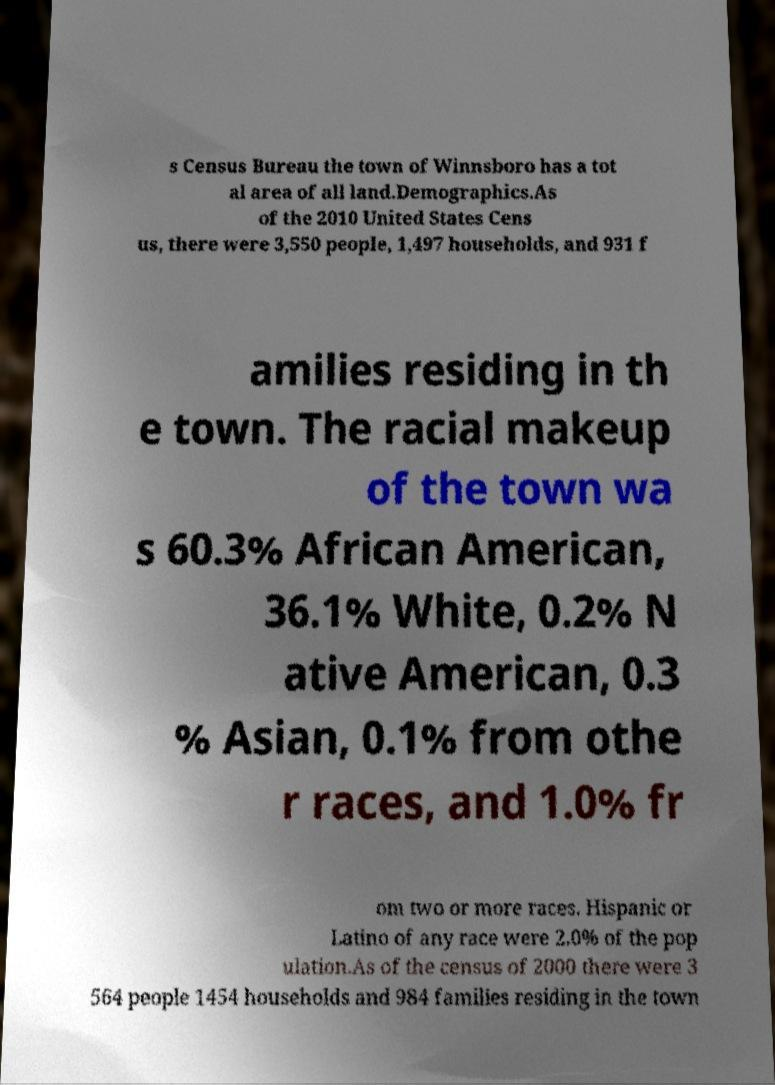Can you read and provide the text displayed in the image?This photo seems to have some interesting text. Can you extract and type it out for me? s Census Bureau the town of Winnsboro has a tot al area of all land.Demographics.As of the 2010 United States Cens us, there were 3,550 people, 1,497 households, and 931 f amilies residing in th e town. The racial makeup of the town wa s 60.3% African American, 36.1% White, 0.2% N ative American, 0.3 % Asian, 0.1% from othe r races, and 1.0% fr om two or more races. Hispanic or Latino of any race were 2.0% of the pop ulation.As of the census of 2000 there were 3 564 people 1454 households and 984 families residing in the town 